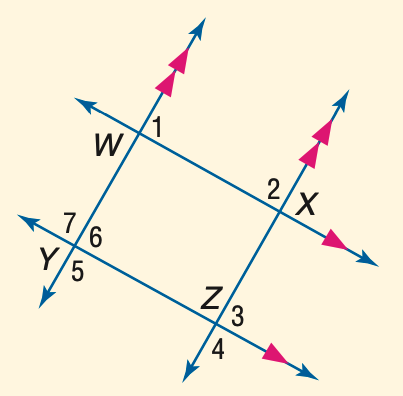Answer the mathemtical geometry problem and directly provide the correct option letter.
Question: In the figure, m \angle 1 = 53. Find the measure of \angle 5.
Choices: A: 113 B: 117 C: 123 D: 127 D 